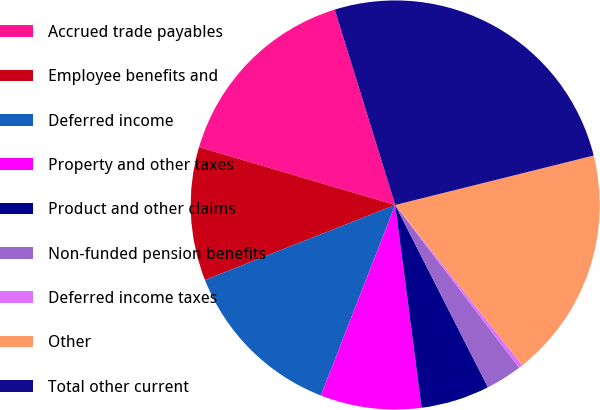<chart> <loc_0><loc_0><loc_500><loc_500><pie_chart><fcel>Accrued trade payables<fcel>Employee benefits and<fcel>Deferred income<fcel>Property and other taxes<fcel>Product and other claims<fcel>Non-funded pension benefits<fcel>Deferred income taxes<fcel>Other<fcel>Total other current<nl><fcel>15.66%<fcel>10.54%<fcel>13.1%<fcel>7.98%<fcel>5.43%<fcel>2.87%<fcel>0.31%<fcel>18.22%<fcel>25.89%<nl></chart> 